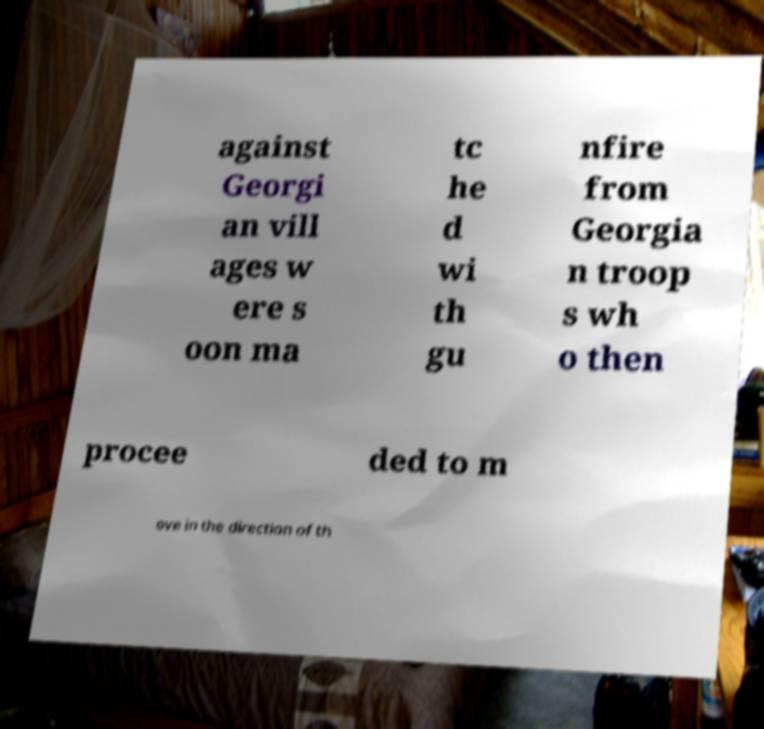Could you assist in decoding the text presented in this image and type it out clearly? against Georgi an vill ages w ere s oon ma tc he d wi th gu nfire from Georgia n troop s wh o then procee ded to m ove in the direction of th 